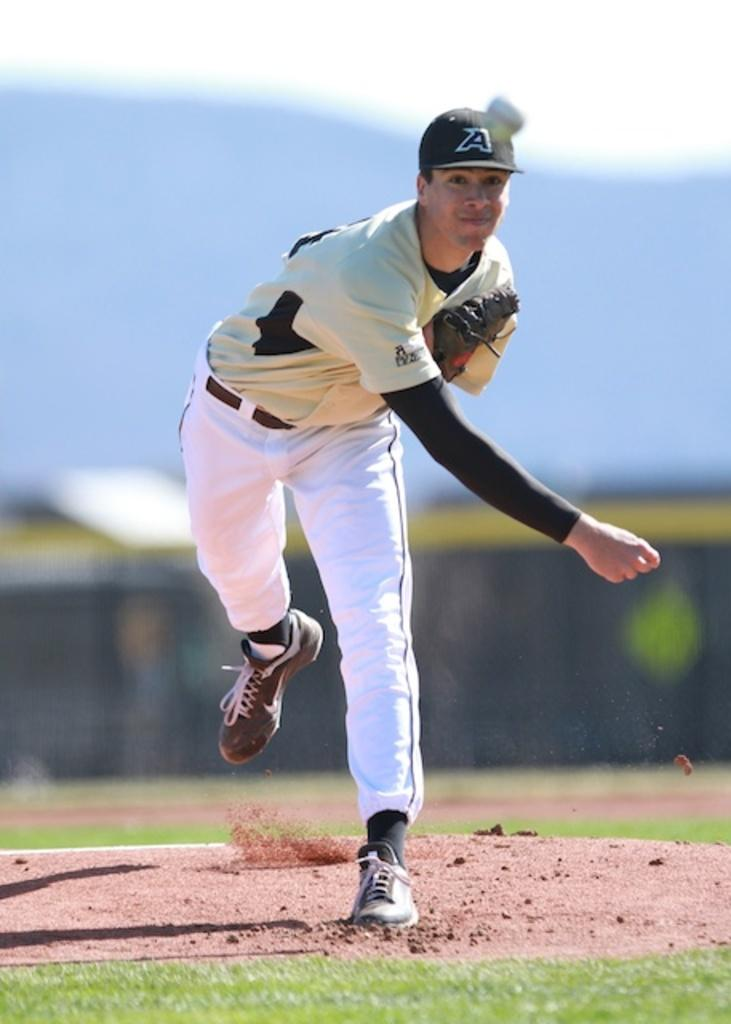<image>
Offer a succinct explanation of the picture presented. The guy pitching off the mound has the letter A on his hat. 